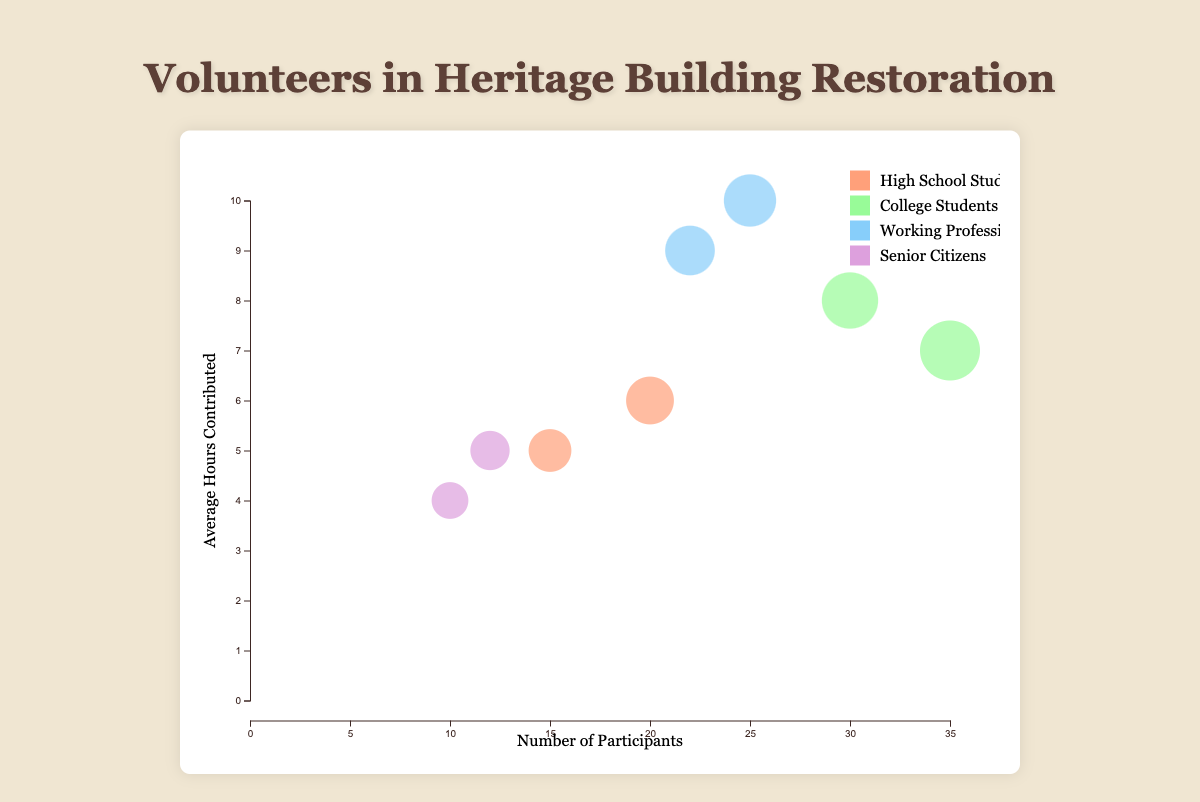What is the title of the chart? The title of the chart is displayed at the top and is usually the most noticeable text. Here, it reads "Volunteers in Heritage Building Restoration".
Answer: Volunteers in Heritage Building Restoration How many unique volunteer groups are participating? By looking at the legend on the right side of the chart, we can count the number of legend items, which represent each volunteer group. There are four groups: "High School Students", "College Students", "Working Professionals", and "Senior Citizens".
Answer: Four Which group has the highest number of female participants? To find this, look for the largest circles among female participants (coded by color and tooltip information). "College Students" have the largest circle for female participants (35).
Answer: College Students What is the average number of hours contributed by male senior citizens? To find this, locate the circle representing male senior citizens. The tooltip or axis positioning shows "Senior Citizens" in the "Male" category contribute an average of 4 hours.
Answer: 4 Compare the participation count between female high school students and female college students. Which one is greater? By checking the circles and tooltip information for "Female" in both "High School Students" and "College Students," we see that female college students participate more (35 vs. 20).
Answer: Female College Students What is the total number of participants in all volunteer groups? Sum the participation counts from all groups: 15 (HS Male) + 20 (HS Female) + 30 (Col Male) + 35 (Col Female) + 25 (WP Male) + 22 (WP Female) + 10 (SC Male) + 12 (SC Female) = 169.
Answer: 169 What does the radius of each bubble represent? The radius of each bubble usually signifies a quantitative measure. Here, it represents the participation count, as larger circles indicate more participants.
Answer: Participation count Which group spends the most average hours contributing to the restoration project? Look at the y-axis positioning for each circle. "Working Professionals" (Male) have the highest average hours contributing (10 hours).
Answer: Working Professionals (Male) How many age groups are represented in this chart? The chart shows "Under 18", "18-25", "26-40", and "Above 60." By counting each unique age group, we find there are 4 unique groups.
Answer: Four 